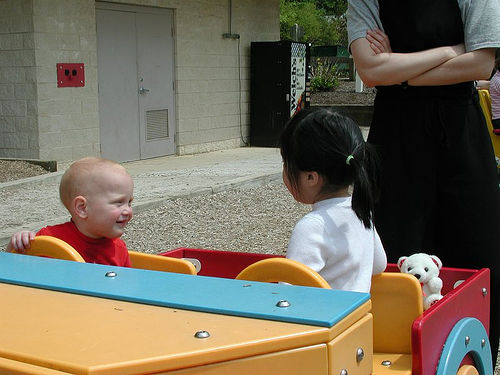Extract all visible text content from this image. WEICH 